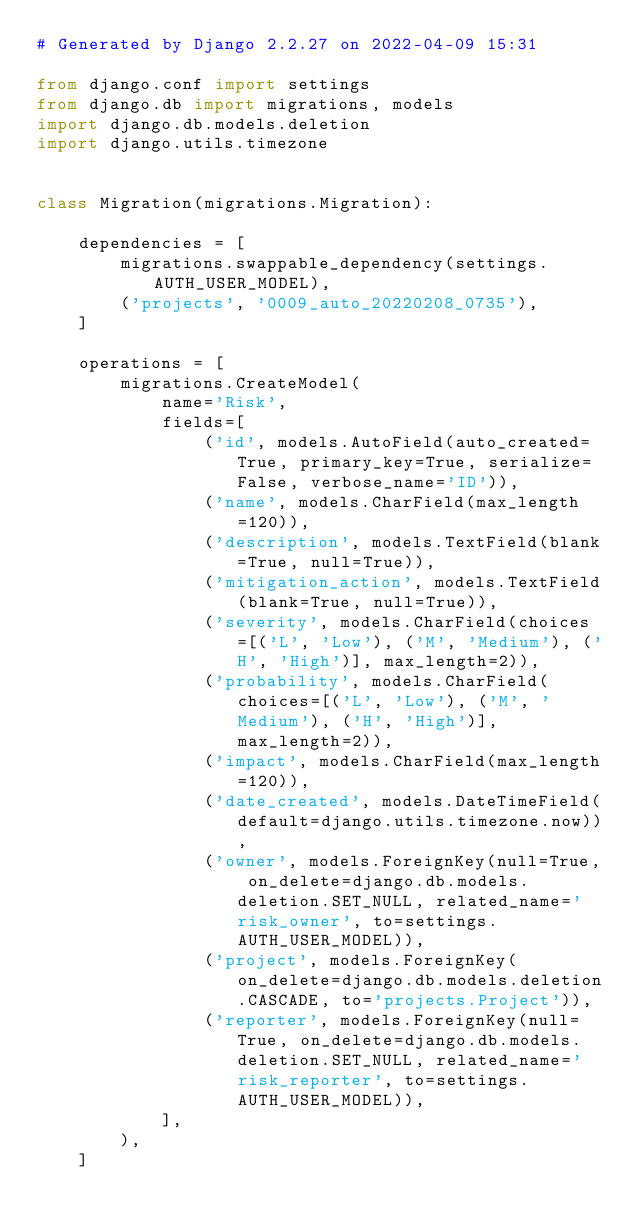<code> <loc_0><loc_0><loc_500><loc_500><_Python_># Generated by Django 2.2.27 on 2022-04-09 15:31

from django.conf import settings
from django.db import migrations, models
import django.db.models.deletion
import django.utils.timezone


class Migration(migrations.Migration):

    dependencies = [
        migrations.swappable_dependency(settings.AUTH_USER_MODEL),
        ('projects', '0009_auto_20220208_0735'),
    ]

    operations = [
        migrations.CreateModel(
            name='Risk',
            fields=[
                ('id', models.AutoField(auto_created=True, primary_key=True, serialize=False, verbose_name='ID')),
                ('name', models.CharField(max_length=120)),
                ('description', models.TextField(blank=True, null=True)),
                ('mitigation_action', models.TextField(blank=True, null=True)),
                ('severity', models.CharField(choices=[('L', 'Low'), ('M', 'Medium'), ('H', 'High')], max_length=2)),
                ('probability', models.CharField(choices=[('L', 'Low'), ('M', 'Medium'), ('H', 'High')], max_length=2)),
                ('impact', models.CharField(max_length=120)),
                ('date_created', models.DateTimeField(default=django.utils.timezone.now)),
                ('owner', models.ForeignKey(null=True, on_delete=django.db.models.deletion.SET_NULL, related_name='risk_owner', to=settings.AUTH_USER_MODEL)),
                ('project', models.ForeignKey(on_delete=django.db.models.deletion.CASCADE, to='projects.Project')),
                ('reporter', models.ForeignKey(null=True, on_delete=django.db.models.deletion.SET_NULL, related_name='risk_reporter', to=settings.AUTH_USER_MODEL)),
            ],
        ),
    ]
</code> 